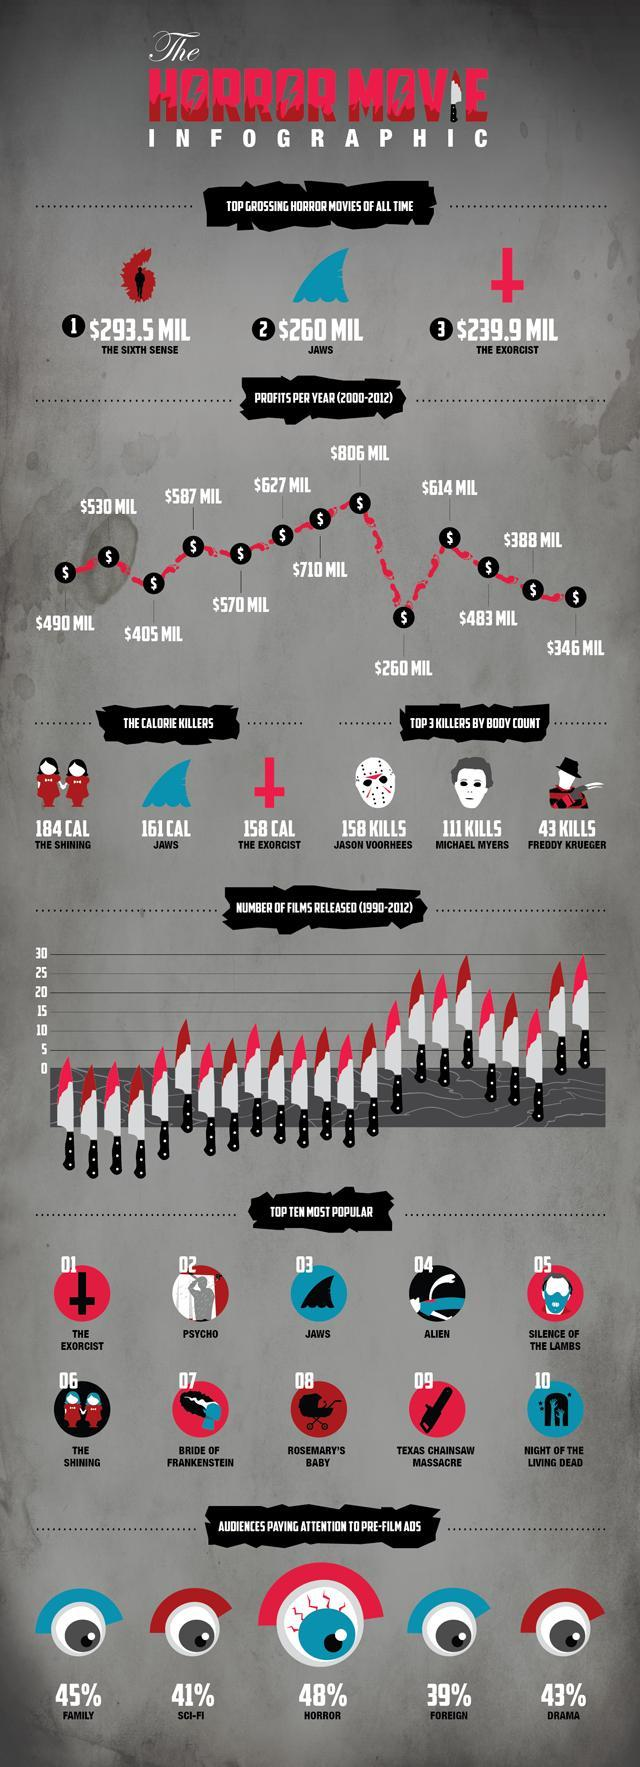Which killer killed the most?
Answer the question with a short phrase. JASON VOORHEES Which is the second most top grossing movies of all time? JAWS 